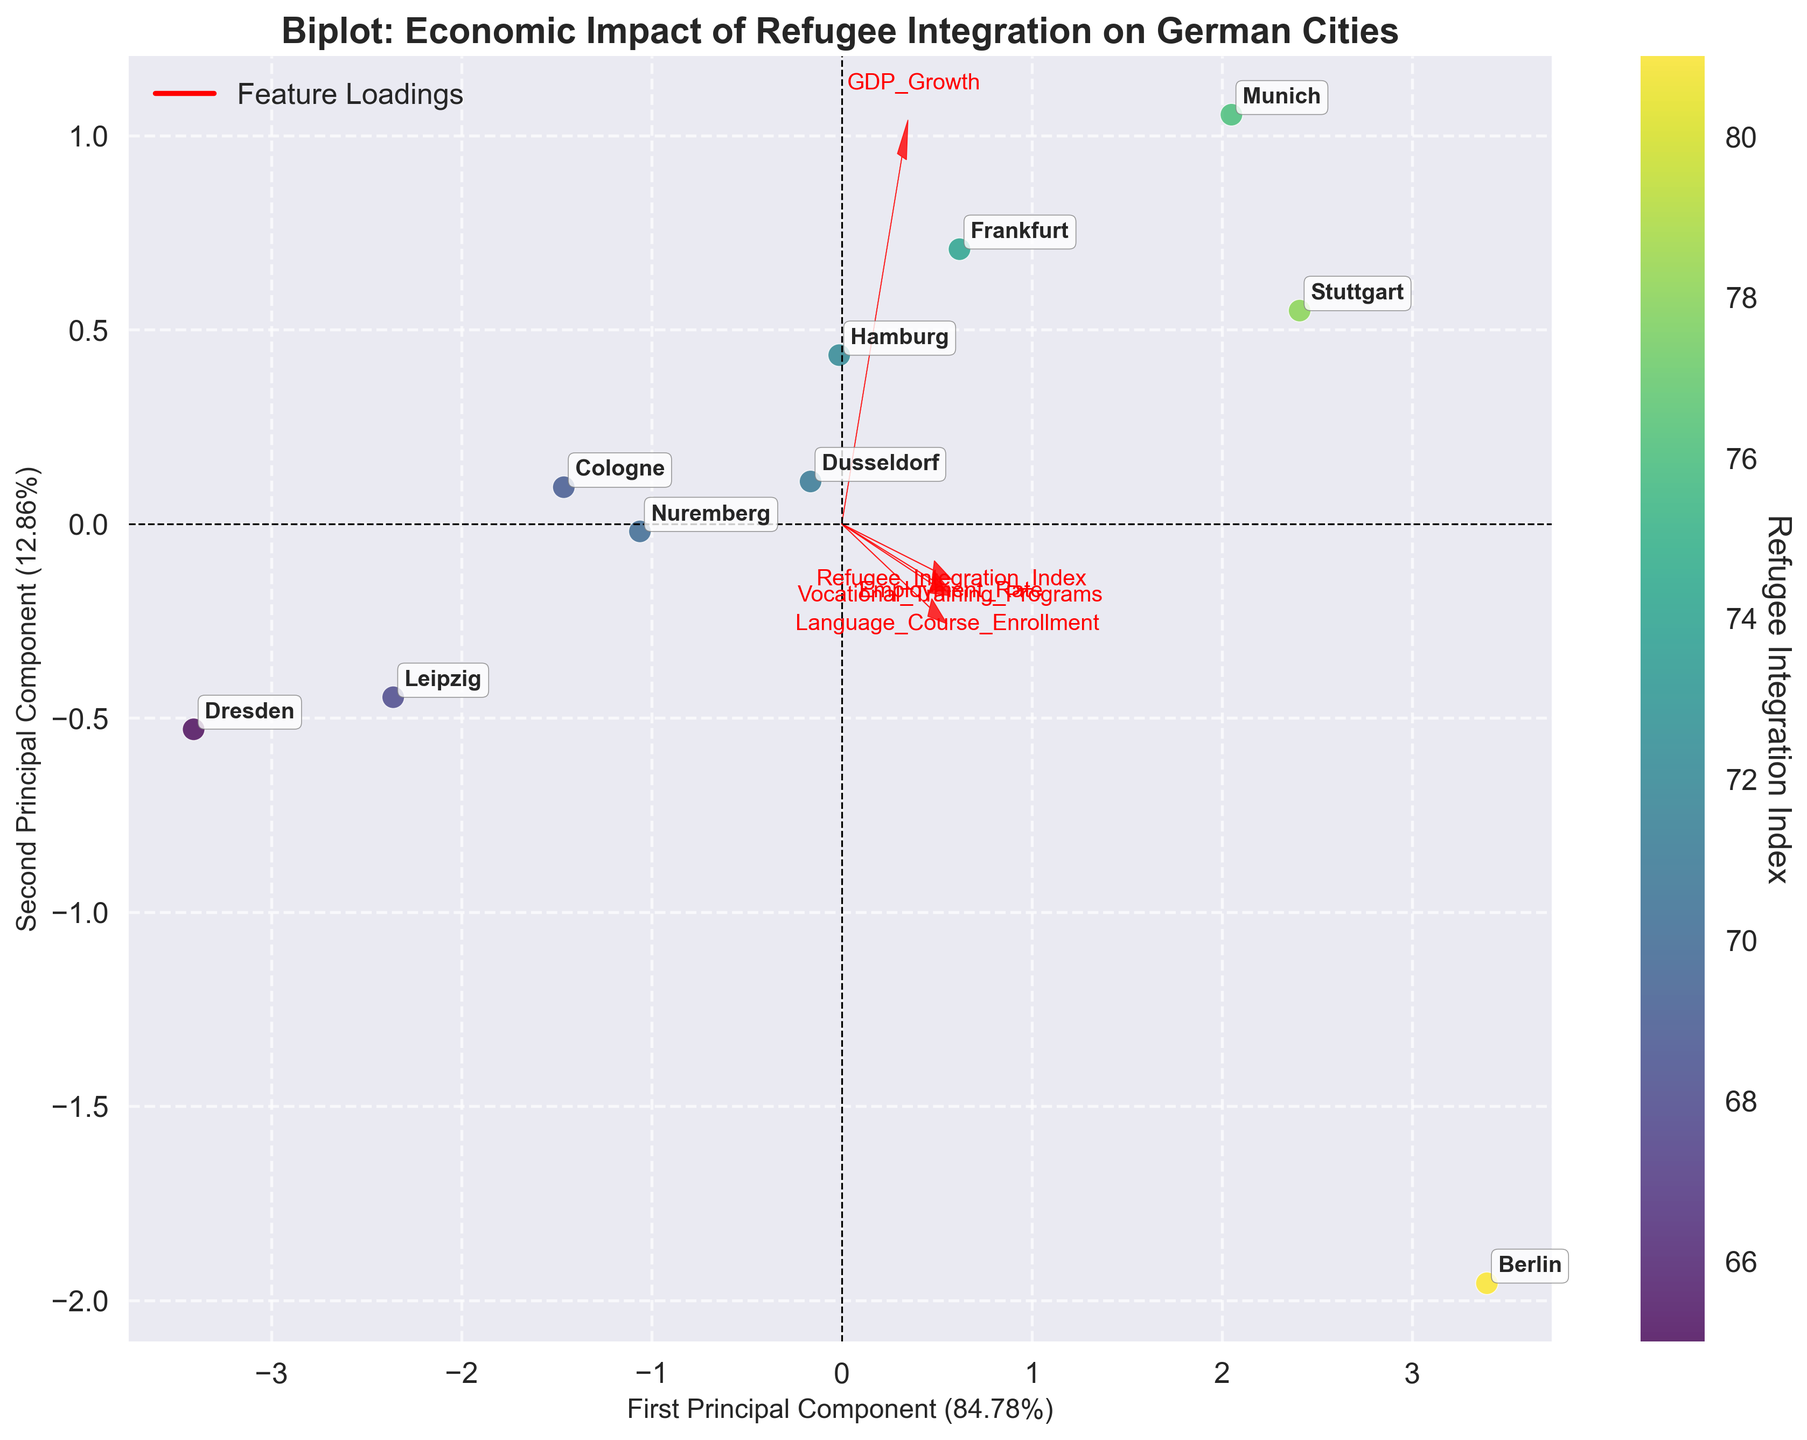what is the title of the figure? Look at the top part of the figure where the title is usually displayed to find the mention of "Biplot: Economic Impact of Refugee Integration on German Cities".
Answer: "Biplot: Economic Impact of Refugee Integration on German Cities" how many principal components are displayed? On the X-axis and Y-axis, look for labels starting with "First Principal Component" and "Second Principal Component", indicating that there are two principal components displayed.
Answer: 2 what city has the highest refugee integration index based on the plot? Identify the color bar indicating the Refugee Integration Index and locate the city with the highest color value, which corresponds to Berlin.
Answer: Berlin which feature strongly influences the first principal component? Find the feature that has the largest arrow along the X-axis direction. The labels on the arrow indicate that "Employment Rate" has the largest vector in the X-axis direction.
Answer: Employment Rate is there a positive correlation between the GDP growth and refugee integration index? Identify the vectors for GDP Growth and Refugee Integration Index. Since both arrows point in a similar direction (positive X and Y axes), there is a positive correlation between GDP Growth and the Refugee Integration Index.
Answer: Yes which two cities are closest to each other in terms of their principal component scores? Identify the two data points that are closest to each other on the XY scatter plot, which are Hamburg and Nuremberg.
Answer: Hamburg and Nuremberg what's the variance explained by the first principal component? Look at the label on the X-axis, which indicates the variance explained by the first principal component in percentage terms (around 72.45%).
Answer: 72.45% between Frankfurt and Stuttgart, which city has a higher vocational training program factor loading? Compare the locations of arrow tips for Frankfurt and Stuttgart along the Vocational Training Programs vector. Since Stuttgart's score on this feature is higher than Frankfurt's, Stuttgart has a higher loading.
Answer: Stuttgart 